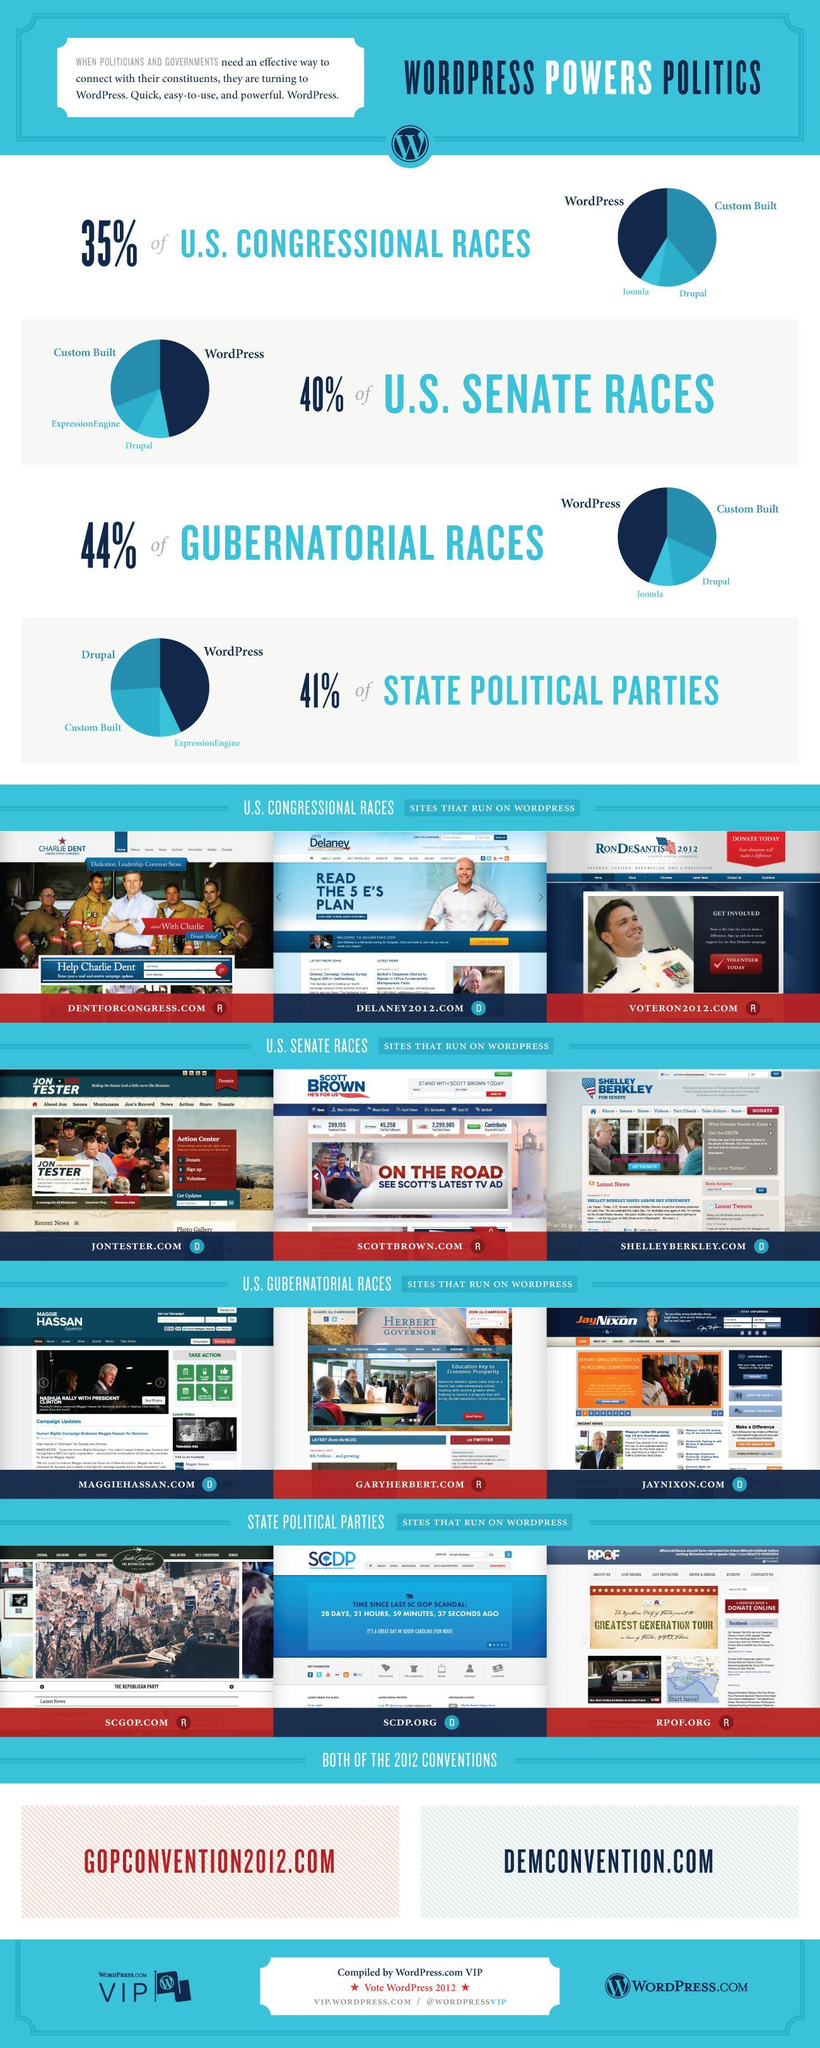What are the options used for U.S. Congressional races to connect with their constituents in addition to WordPress
Answer the question with a short phrase. Custom Built, Joomla, Drupal Which are the sites that run on wordpress for U.S. COngressional Races DENTFORCONGRESS.COM, DELANEY2012.COM, VOTERON2012.COM What are the 3 points shown in the action center of  website JONTESTER.COM Donate, Sign up, Volunteer Which are the websites of state political parties that run on wordpress SCGOP.COM, SCDP.ORG, RPOF.ORG 